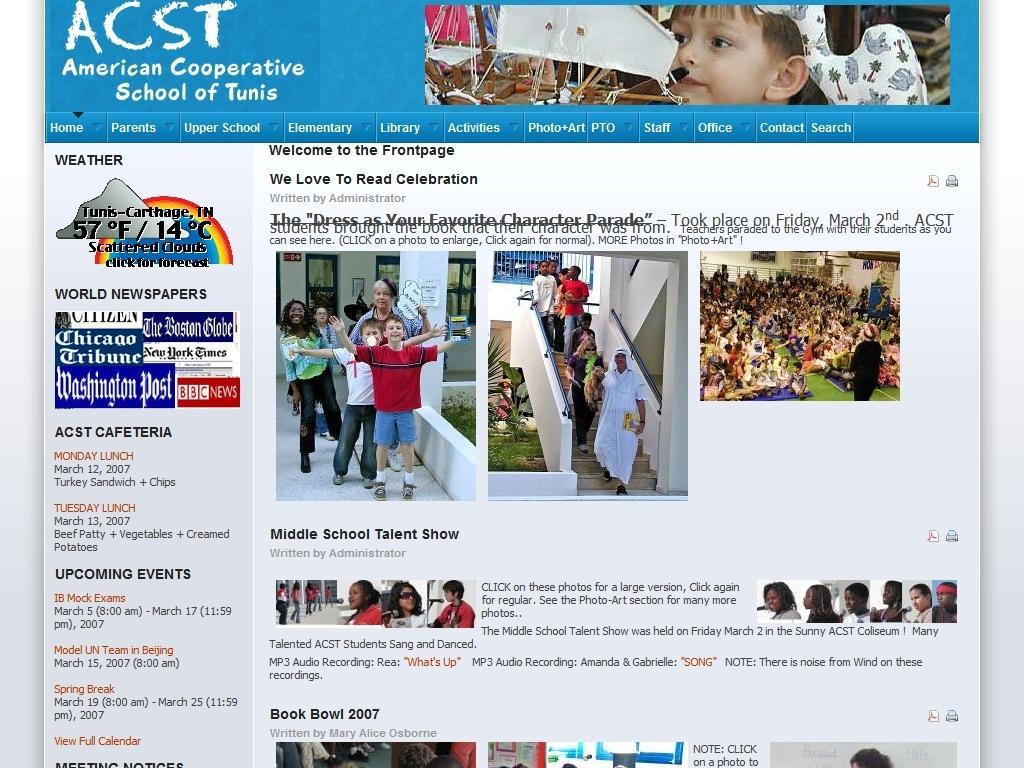Describe this image in one or two sentences. In this image we can see a screenshot of a website, which consists of some text and images of people in it. 